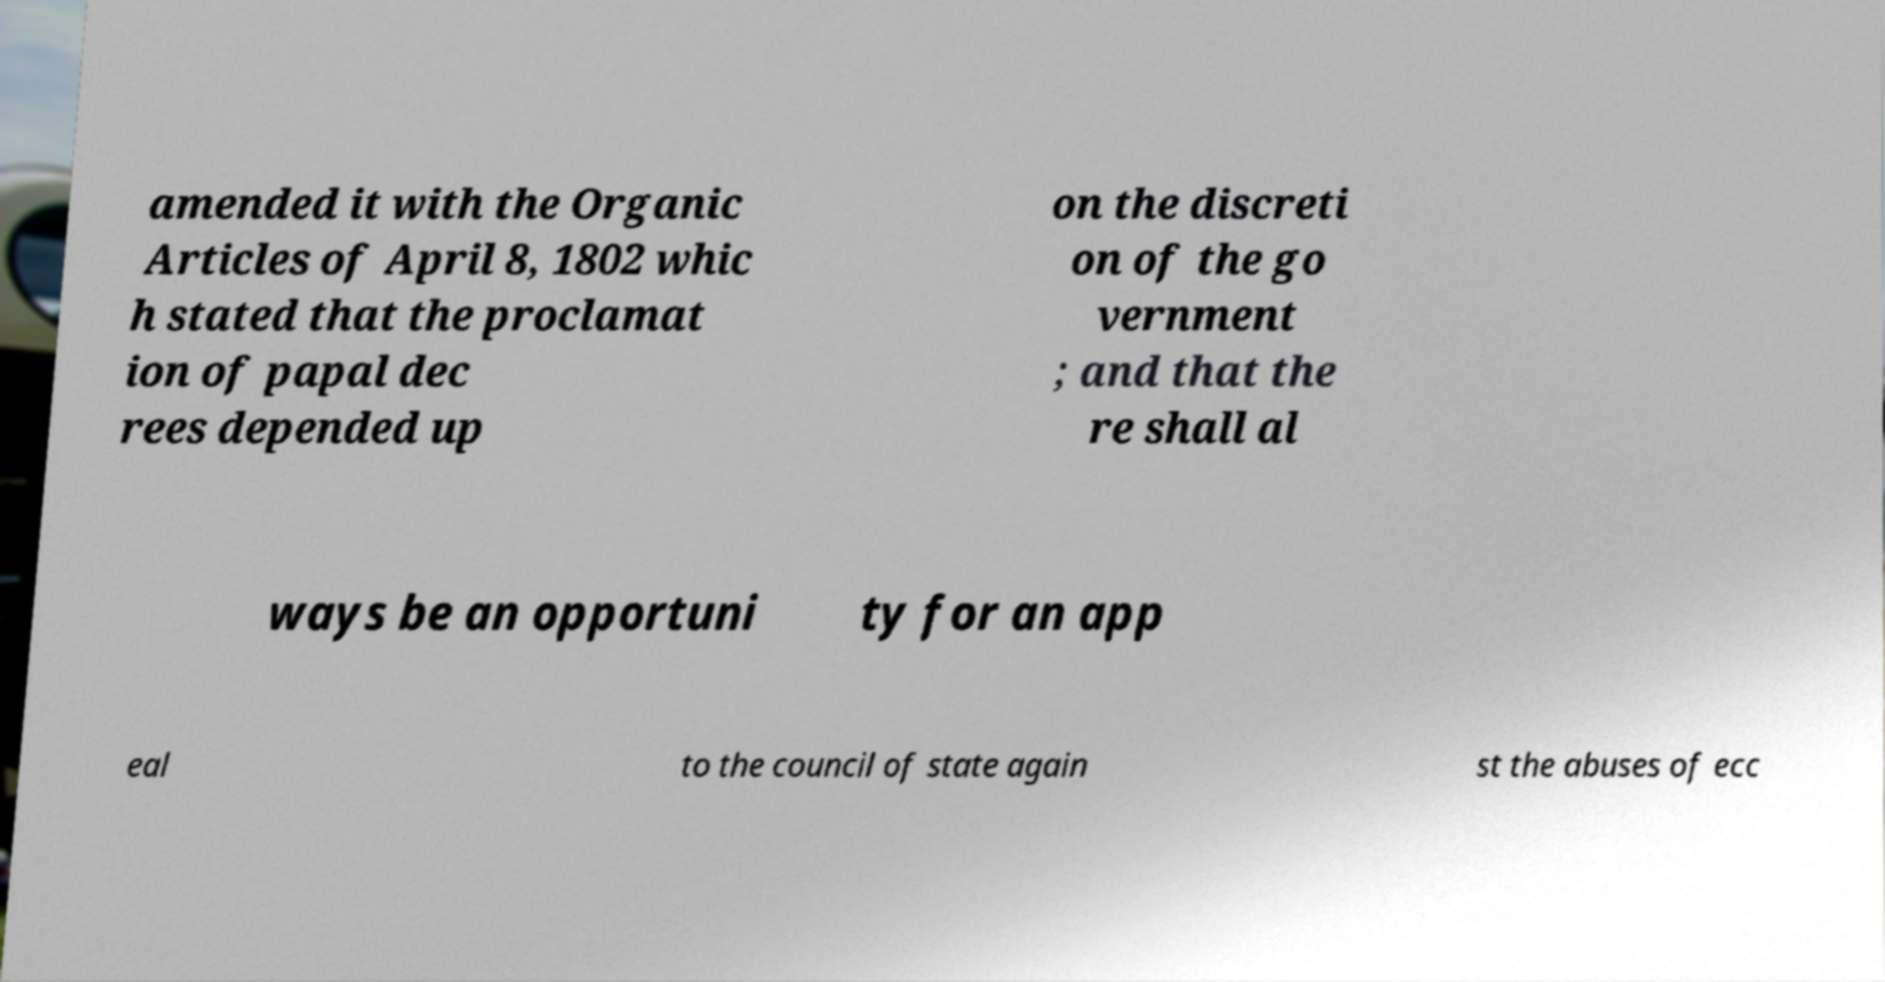For documentation purposes, I need the text within this image transcribed. Could you provide that? amended it with the Organic Articles of April 8, 1802 whic h stated that the proclamat ion of papal dec rees depended up on the discreti on of the go vernment ; and that the re shall al ways be an opportuni ty for an app eal to the council of state again st the abuses of ecc 